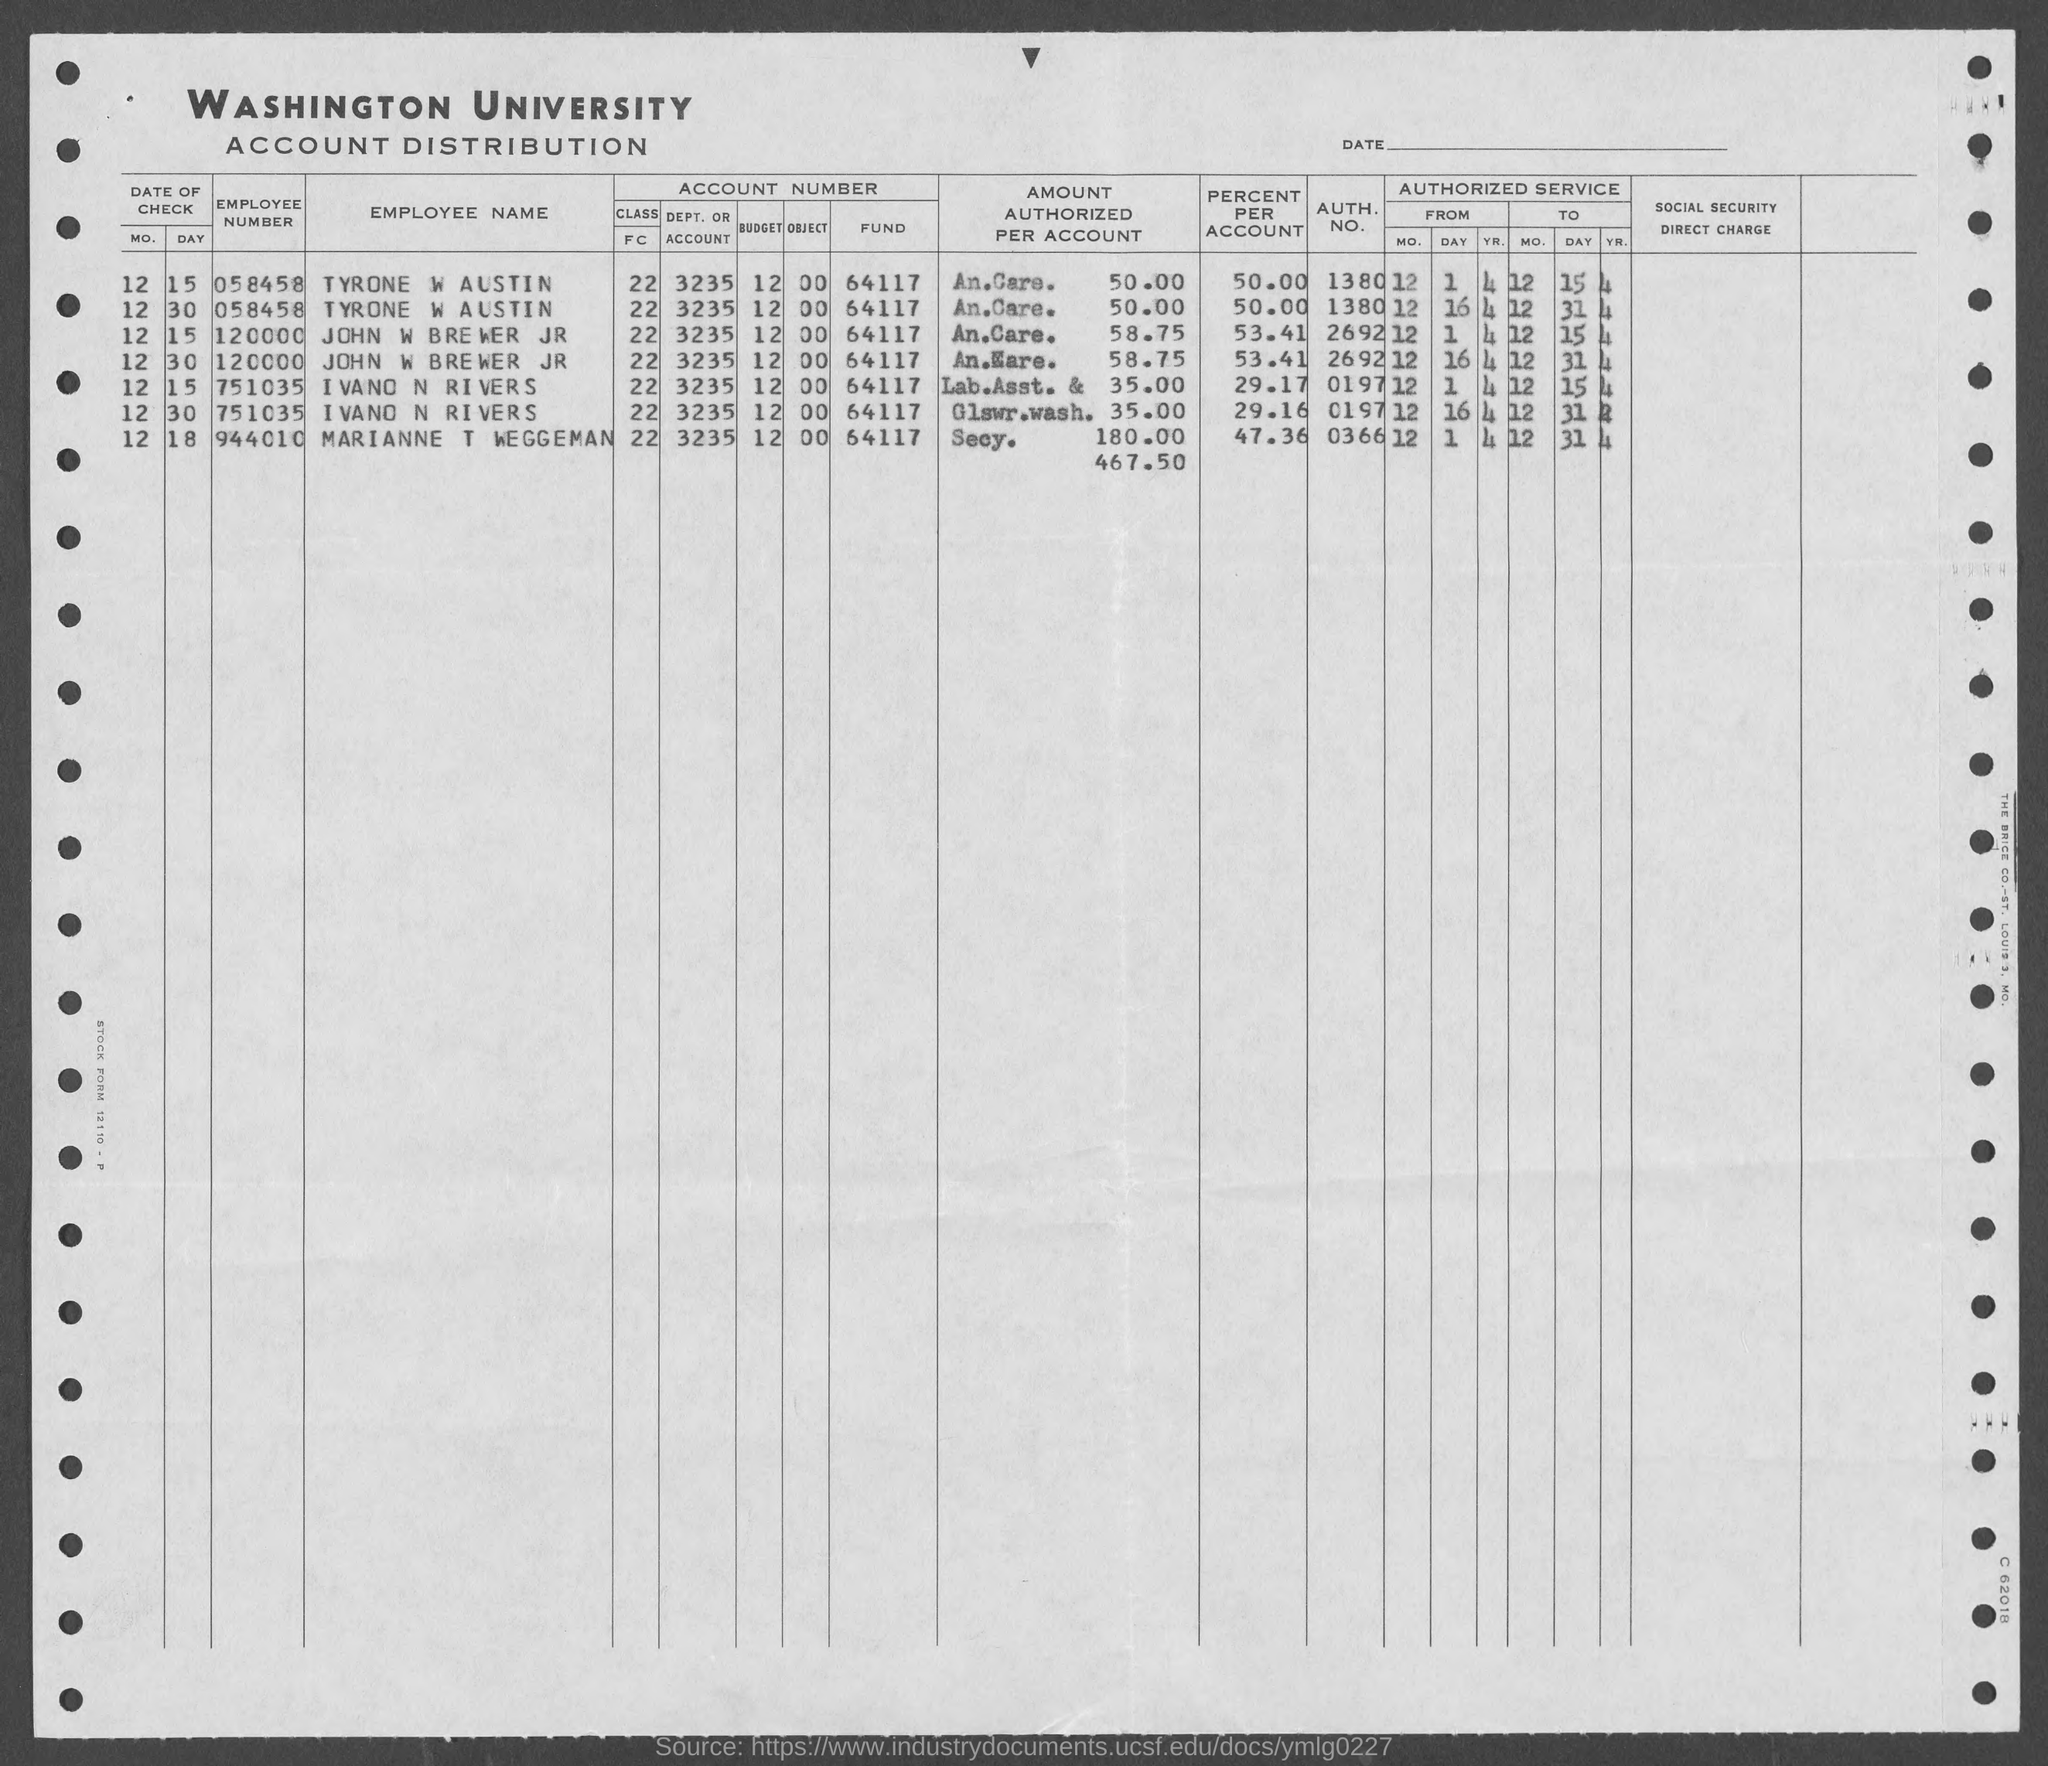What is the employee number of tyrone w austin ?
Your answer should be compact. 058458. What is the employee number of john w brewer jr ?
Keep it short and to the point. 120000. What is the employee number of ivano n rivers ?
Offer a very short reply. 751035. What is the employee number of marianne t weggeman ?
Your answer should be compact. 944010. What is the auth. no. of tyrone w austin ?
Make the answer very short. 1380. What is the auth. no. of ivano n. rivers?
Offer a terse response. 0197. What is the auth. no. of John W Brewer Jr ?
Ensure brevity in your answer.  2692. What is the auth. no. of marianne t  weggeman?
Your response must be concise. 0366. What is the percent per account of marianne t weggeman ?
Give a very brief answer. 47.36. What is the percent per account of tyrone w austin ?
Ensure brevity in your answer.  50.00%. 